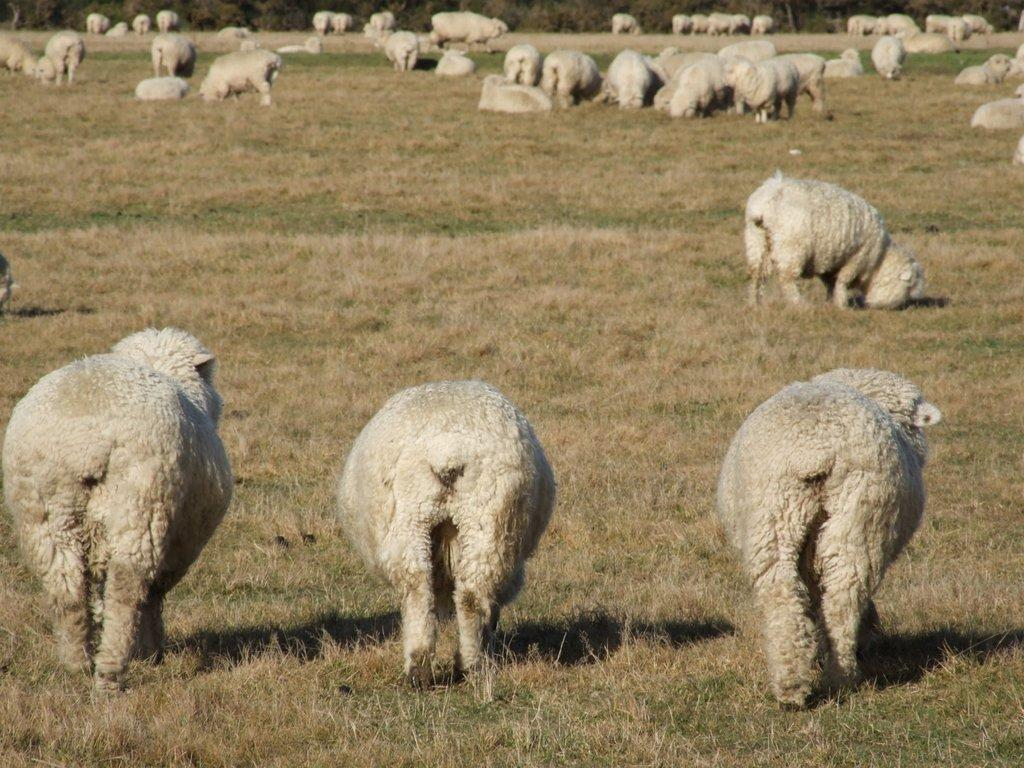What are the animals in the image doing? The animals in the image are standing on the ground. Are there any animals in the background of the image? Yes, there are animals standing on the ground in the background. What else can be seen in the background of the image? In the background, there are animals sitting on the ground. What type of vegetation is visible in the background? Trees are visible in the background. What type of brick is being used to build the hand in the image? There is no brick or hand present in the image; it features animals standing and sitting on the ground. 